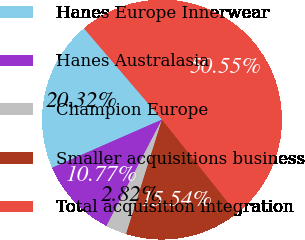Convert chart to OTSL. <chart><loc_0><loc_0><loc_500><loc_500><pie_chart><fcel>Hanes Europe Innerwear<fcel>Hanes Australasia<fcel>Champion Europe<fcel>Smaller acquisitions business<fcel>Total acquisition integration<nl><fcel>20.32%<fcel>10.77%<fcel>2.82%<fcel>15.54%<fcel>50.55%<nl></chart> 